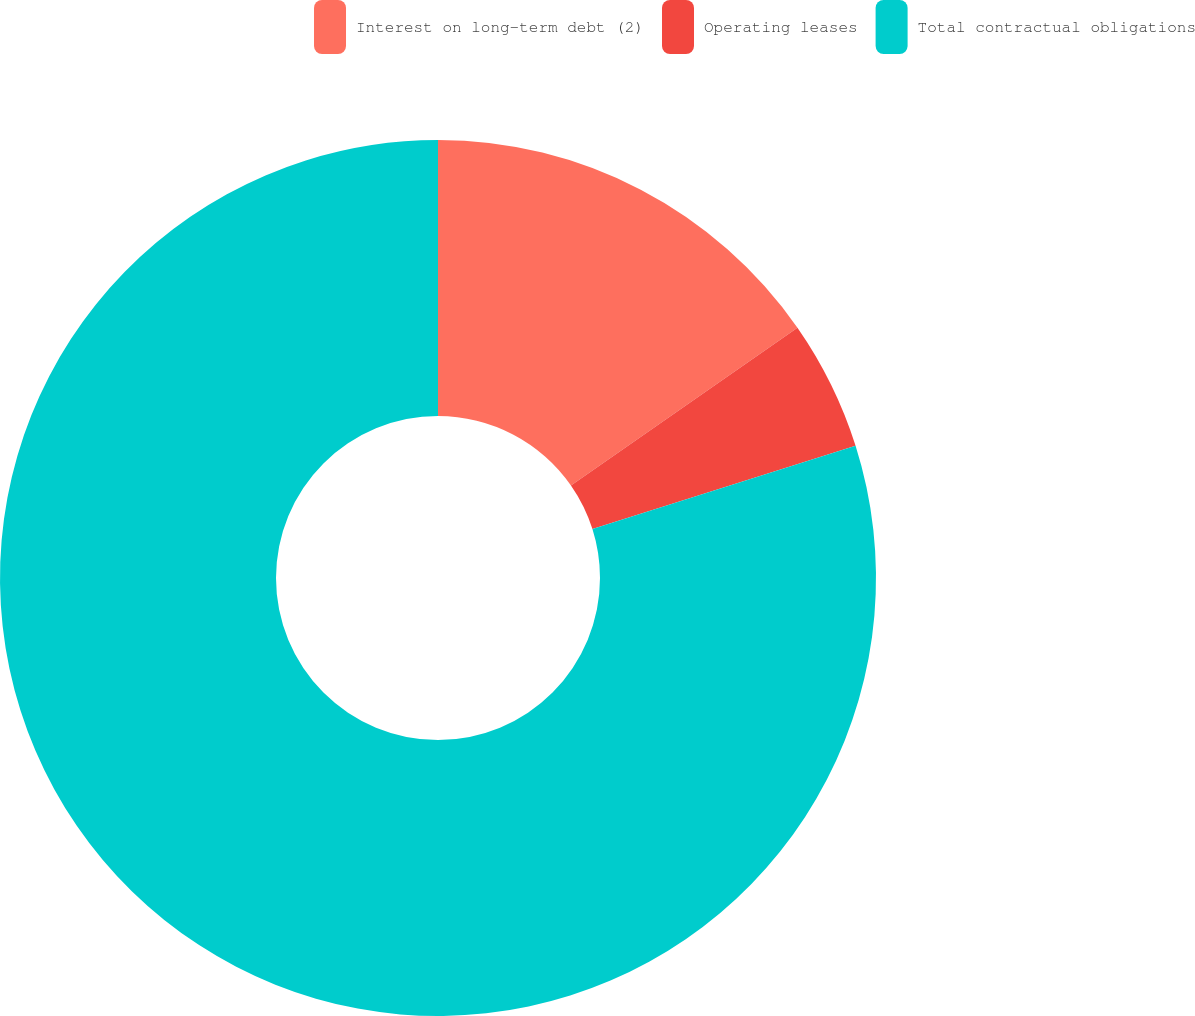Convert chart. <chart><loc_0><loc_0><loc_500><loc_500><pie_chart><fcel>Interest on long-term debt (2)<fcel>Operating leases<fcel>Total contractual obligations<nl><fcel>15.32%<fcel>4.8%<fcel>79.88%<nl></chart> 